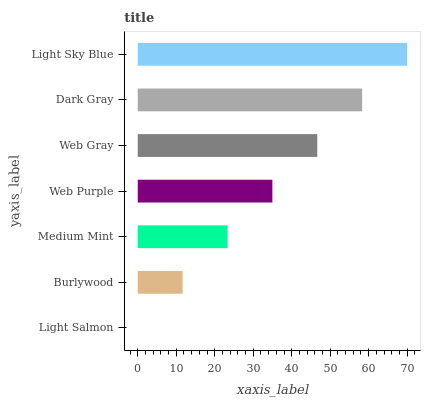Is Light Salmon the minimum?
Answer yes or no. Yes. Is Light Sky Blue the maximum?
Answer yes or no. Yes. Is Burlywood the minimum?
Answer yes or no. No. Is Burlywood the maximum?
Answer yes or no. No. Is Burlywood greater than Light Salmon?
Answer yes or no. Yes. Is Light Salmon less than Burlywood?
Answer yes or no. Yes. Is Light Salmon greater than Burlywood?
Answer yes or no. No. Is Burlywood less than Light Salmon?
Answer yes or no. No. Is Web Purple the high median?
Answer yes or no. Yes. Is Web Purple the low median?
Answer yes or no. Yes. Is Light Salmon the high median?
Answer yes or no. No. Is Medium Mint the low median?
Answer yes or no. No. 